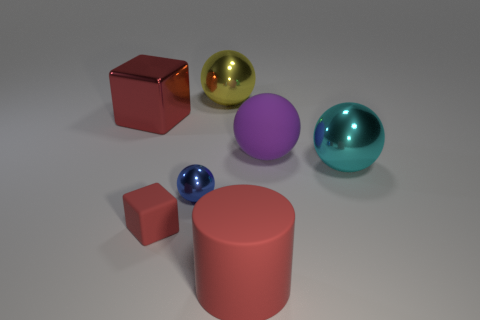Subtract all yellow spheres. How many spheres are left? 3 Subtract all red spheres. Subtract all blue blocks. How many spheres are left? 4 Add 1 purple things. How many objects exist? 8 Subtract all balls. How many objects are left? 3 Subtract all large cylinders. Subtract all purple blocks. How many objects are left? 6 Add 5 red cylinders. How many red cylinders are left? 6 Add 2 blue shiny objects. How many blue shiny objects exist? 3 Subtract 0 cyan blocks. How many objects are left? 7 